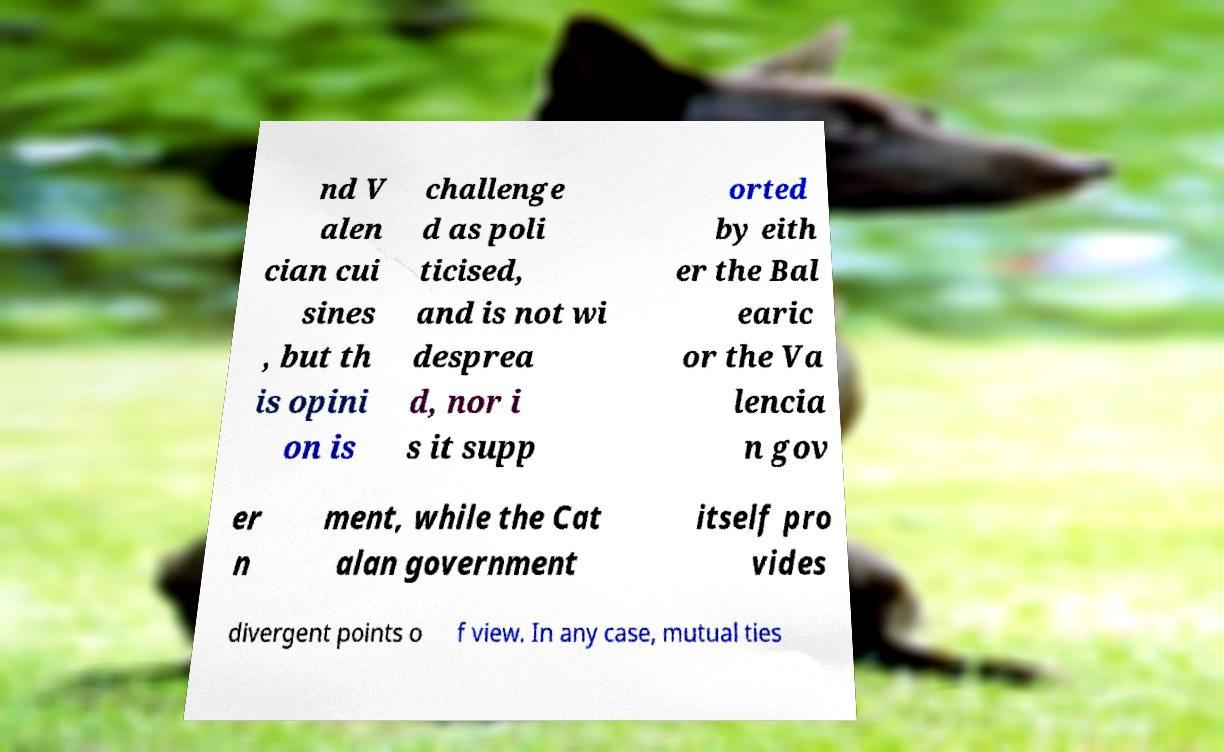Please read and relay the text visible in this image. What does it say? nd V alen cian cui sines , but th is opini on is challenge d as poli ticised, and is not wi desprea d, nor i s it supp orted by eith er the Bal earic or the Va lencia n gov er n ment, while the Cat alan government itself pro vides divergent points o f view. In any case, mutual ties 